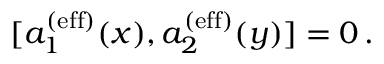<formula> <loc_0><loc_0><loc_500><loc_500>[ a _ { 1 } ^ { ( e f f ) } ( x ) , a _ { 2 } ^ { ( e f f ) } ( y ) ] = 0 \, .</formula> 